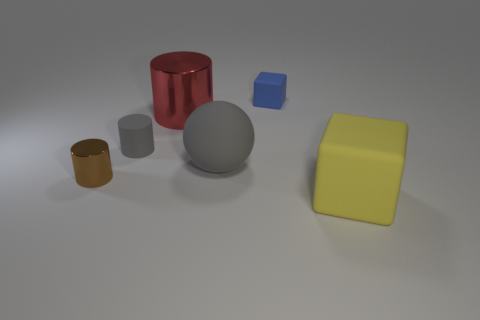Add 2 yellow blocks. How many objects exist? 8 Subtract all cubes. How many objects are left? 4 Subtract 0 green cylinders. How many objects are left? 6 Subtract all big cylinders. Subtract all red cylinders. How many objects are left? 4 Add 5 gray cylinders. How many gray cylinders are left? 6 Add 4 cubes. How many cubes exist? 6 